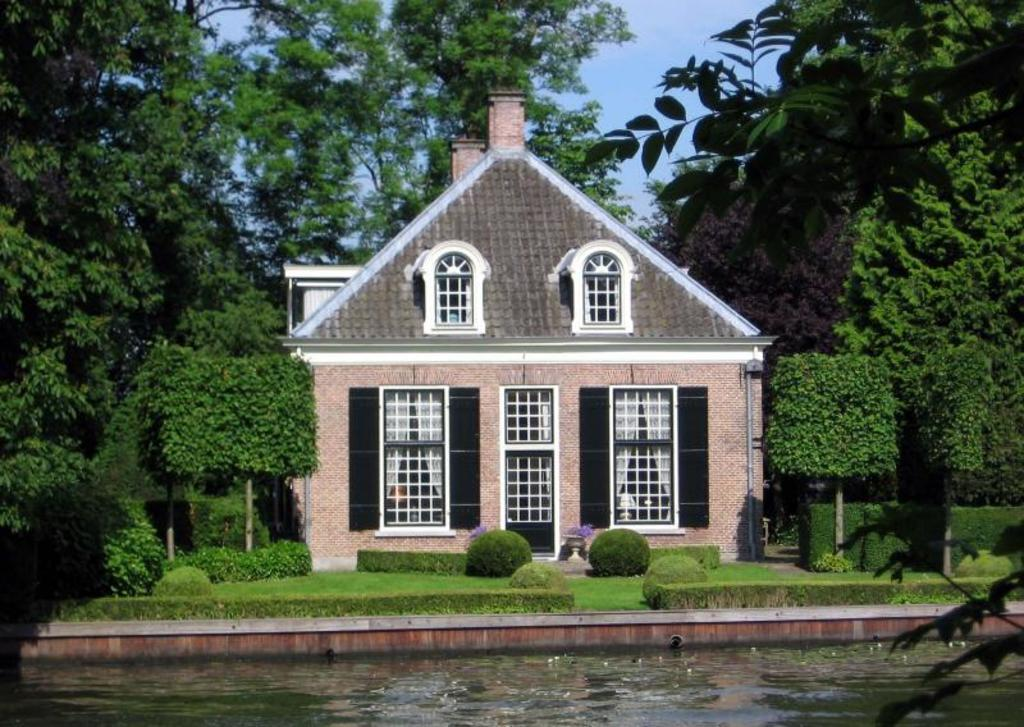What is visible in the image? There is water, a house with windows, plants, trees, and the sky visible in the image. Can you describe the house in the image? The house has windows and is surrounded by plants. What is in the background of the image? There are many trees and the sky visible in the background of the image. Where is the gate located in the image? There is no gate present in the image. What type of bed can be seen in the image? There is no bed present in the image. 